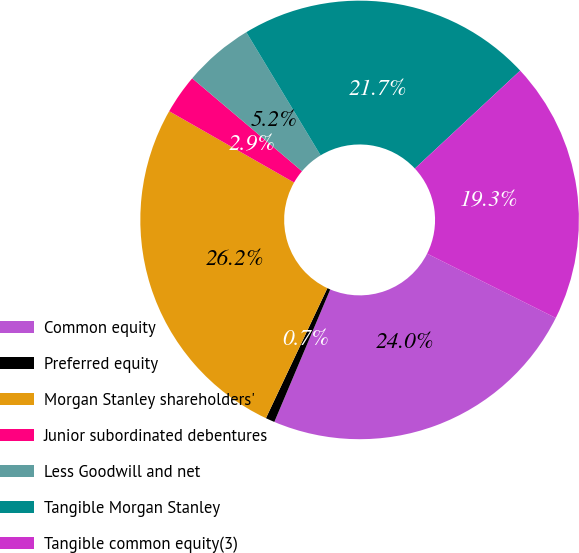<chart> <loc_0><loc_0><loc_500><loc_500><pie_chart><fcel>Common equity<fcel>Preferred equity<fcel>Morgan Stanley shareholders'<fcel>Junior subordinated debentures<fcel>Less Goodwill and net<fcel>Tangible Morgan Stanley<fcel>Tangible common equity(3)<nl><fcel>23.98%<fcel>0.67%<fcel>26.23%<fcel>2.92%<fcel>5.18%<fcel>21.72%<fcel>19.3%<nl></chart> 